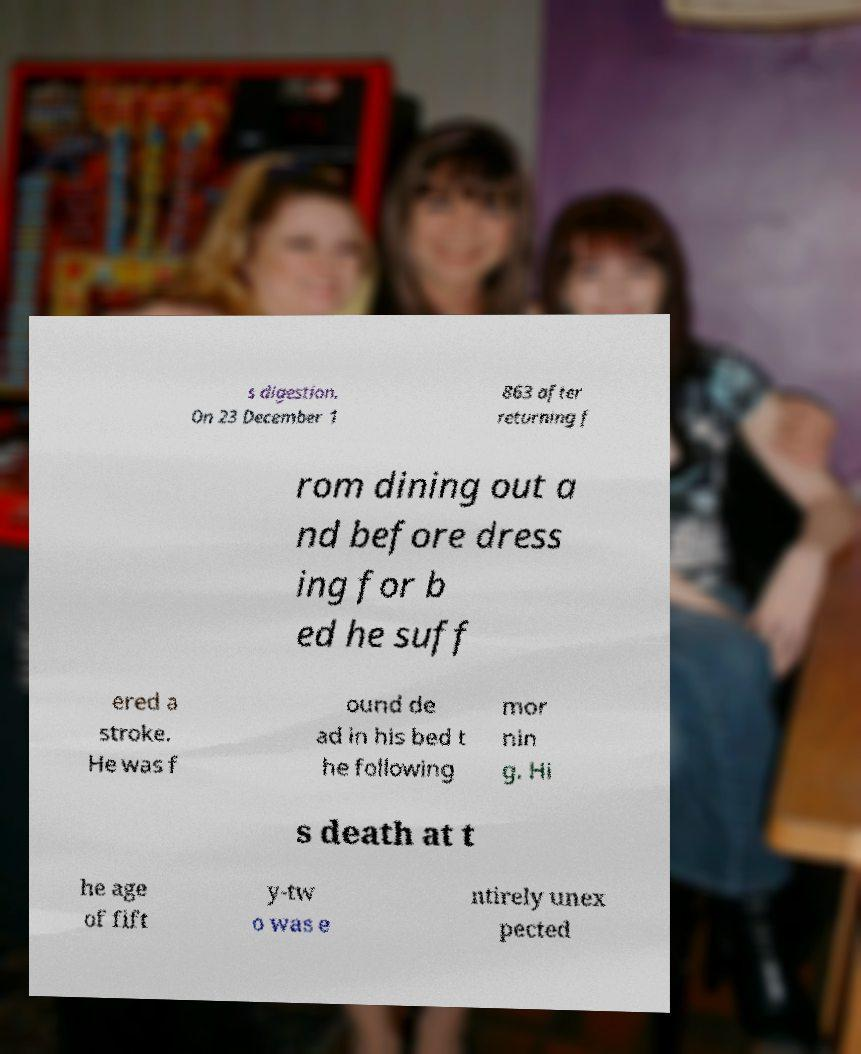Could you extract and type out the text from this image? s digestion. On 23 December 1 863 after returning f rom dining out a nd before dress ing for b ed he suff ered a stroke. He was f ound de ad in his bed t he following mor nin g. Hi s death at t he age of fift y-tw o was e ntirely unex pected 